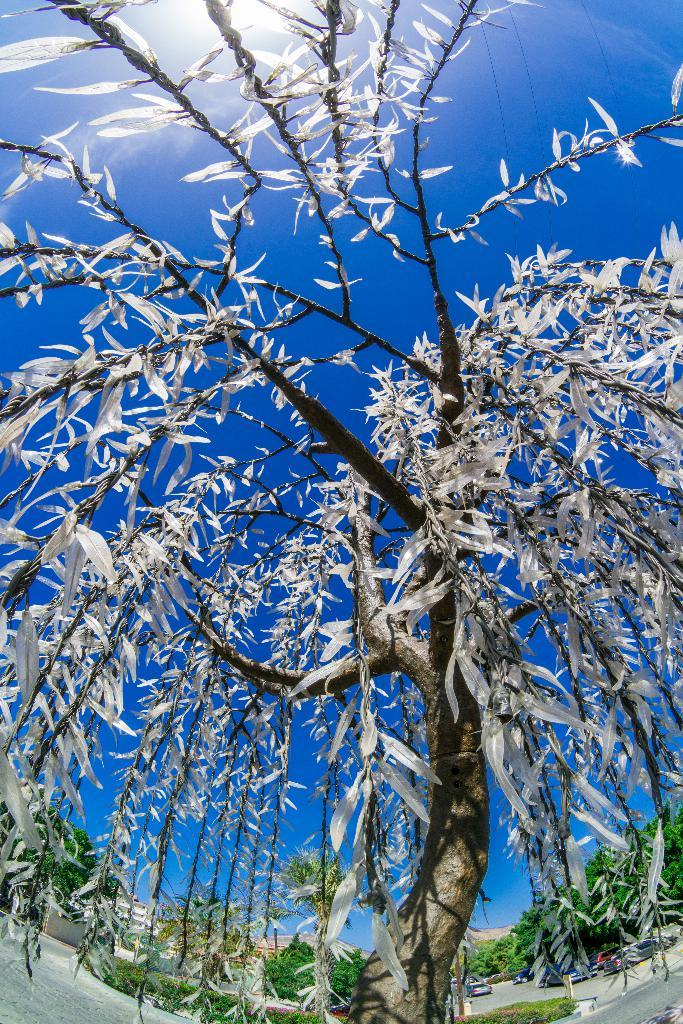What is the main subject in the center of the image? There is a tree in the center of the image. How many people are in the crowd surrounding the tree in the image? There is no crowd present in the image; it only features a tree. What type of net is hanging from the branches of the tree in the image? There is no net present in the image; it only features a tree. 